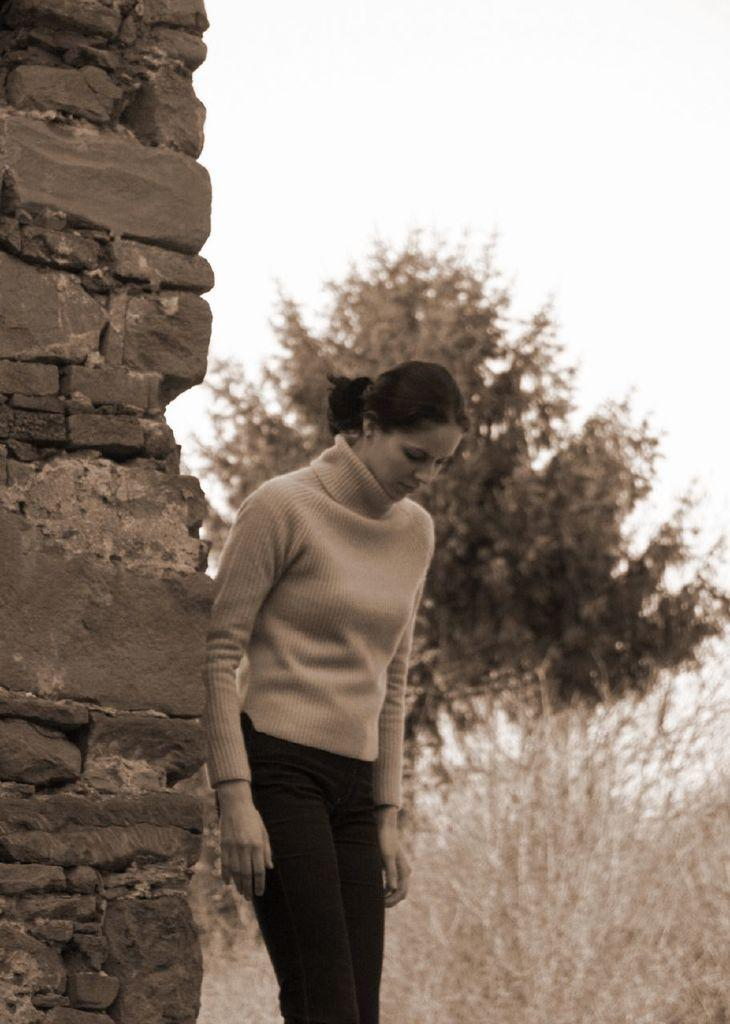What is the main subject of the image? There is a person standing in the image. What can be seen in the background of the image? There are trees and the sky visible in the background of the image. What is the color scheme of the image? The image is in black and white. What type of grass is growing around the cannon in the image? There is no cannon or grass present in the image; it features a person standing in front of trees and the sky. 